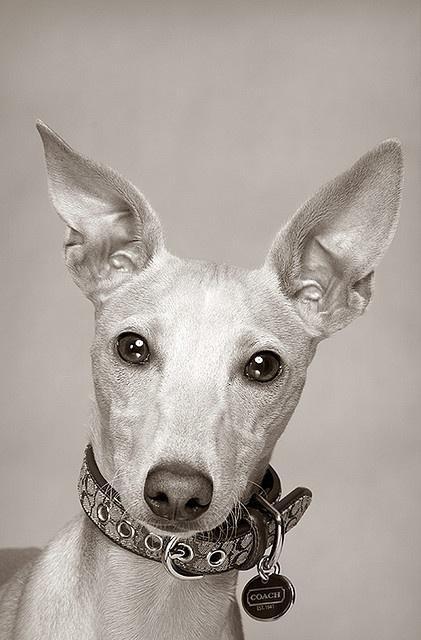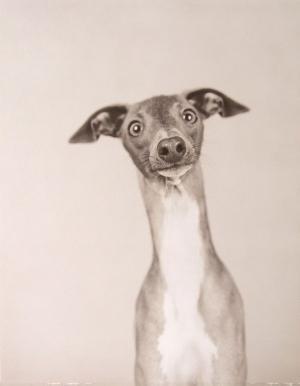The first image is the image on the left, the second image is the image on the right. Examine the images to the left and right. Is the description "An image shows a hound wearing a pearl-look necklace." accurate? Answer yes or no. No. The first image is the image on the left, the second image is the image on the right. Assess this claim about the two images: "A dog with a necklace is lying down in one of the images.". Correct or not? Answer yes or no. No. 